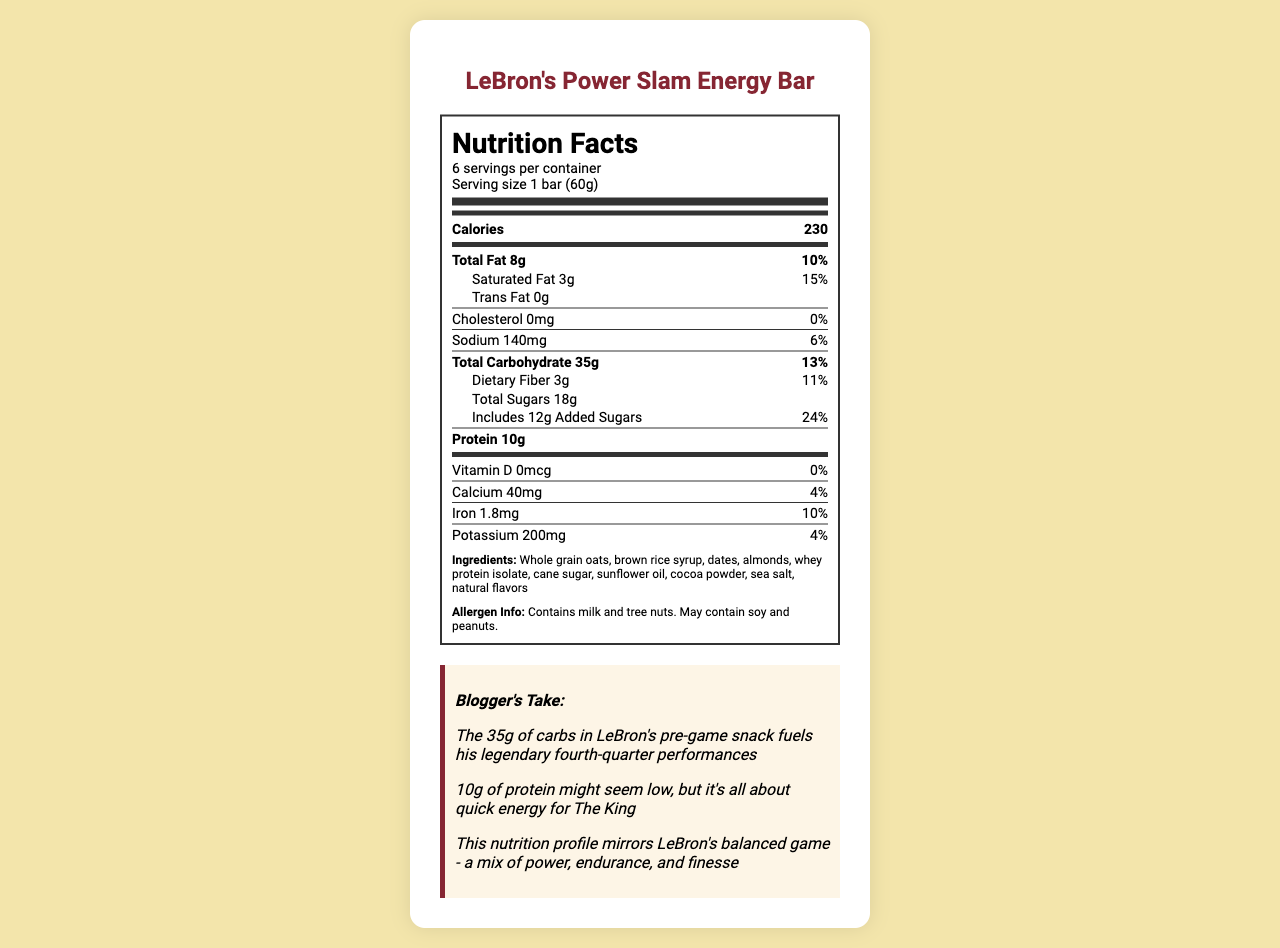what is the serving size for LeBron's Power Slam Energy Bar? The serving size is explicitly mentioned in the serving information section and is noted as 1 bar (60g).
Answer: 1 bar (60g) how many servings are there per container? The document specifically states that there are 6 servings per container.
Answer: 6 how many total carbohydrates are in a single serving of LeBron's Power Slam Energy Bar? The total carbohydrate content per serving is listed as 35g in the nutrient information section.
Answer: 35g what is the percentage of the daily value for added sugars in a serving of this energy bar? The document indicates that the added sugars are 12g per serving and it makes up 24% of the daily value.
Answer: 24% how much protein is there in one serving? The protein content per serving is stated to be 10g.
Answer: 10g which ingredient is listed first in the ingredients list? The first ingredient listed is Whole grain oats.
Answer: Whole grain oats what is the percentage of the daily value for saturated fat? The saturated fat content is 3g, which corresponds to 15% of the daily value.
Answer: 15% is there any cholesterol in this energy bar? The document indicates that the cholesterol content is 0mg, which is 0% of the daily value.
Answer: No what is the total fat content in one serving? The total fat content per serving is listed as 8g.
Answer: 8g does the energy bar contain any allergens? The allergen information states that the bar contains milk and tree nuts and may contain soy and peanuts.
Answer: Yes how many calories are in one serving of the energy bar? The calories per serving are listed as 230.
Answer: 230 what is the main ingredient used in the energy bar? A. Dates B. Almonds C. Whole grain oats D. Cane sugar Whole grain oats are the first ingredient listed, indicating it is the main ingredient.
Answer: C. Whole grain oats which nutrient has the highest daily value percentage? A. Sodium B. Dietary Fiber C. Added Sugars D. Iron Added sugars have the highest daily value percentage at 24%.
Answer: C. Added Sugars is the document primarily about the protein content of the energy bar? The document contains a detailed nutritional breakdown of LeBron's Power Slam Energy Bar, not focusing solely on protein content.
Answer: No summarize the main nutritional aspects of LeBron's Power Slam Energy Bar. The document outlines the nutritional elements of the energy bar, emphasizing its carbohydrate content for energy, moderate protein for quick digestion, and a mix of other nutrients to maintain balance. It also includes ingredients and allergen information.
Answer: LeBron's Power Slam Energy Bar provides 230 calories per serving with 8g of total fat, 35g of carbohydrates, including 18g of total sugars (12g added sugars), and 10g of protein. It also details the daily value percentages for various nutrients and lists the ingredients and allergens. The bar is designed to provide balanced energy, possibly contributing to LeBron James' performance. what is the exact amount of iron in the energy bar? The document indicates that each serving contains 1.8mg of iron.
Answer: 1.8mg where can you find the detailed list of ingredients used in the energy bar? The ingredients are listed in the section labeled 'Ingredients' towards the end of the document.
Answer: In the ingredients section at the bottom of the nutrition label what ingredient might provide the majority of the carbohydrate content? Considering oats are the main ingredient and are high in carbohydrates, they likely provide a significant portion of the carbohydrate content.
Answer: Whole grain oats how does the daily value percentage of sodium compare to that of added sugars? The sodium content contributes 6% of the daily value, while added sugars contribute 24%, making added sugars significantly higher in daily value percentage compared to sodium.
Answer: Sodium: 6%, Added Sugars: 24% how does the document connect LeBron's game performance to the bar's nutritional profile? The blogger notes highlight the carbohydrate content's importance in LeBron's performance, relating the bar's nutritional profile to his energy and endurance on the basketball court.
Answer: It mentions that the 35g of carbs in the bar fuel his legendary fourth-quarter performances, emphasizing the bar's role in providing the energy necessary for his endurance and power during games. is there information on whether this energy bar contains artificial additives? The document does not provide specific details about the presence or absence of artificial additives.
Answer: Not enough information 